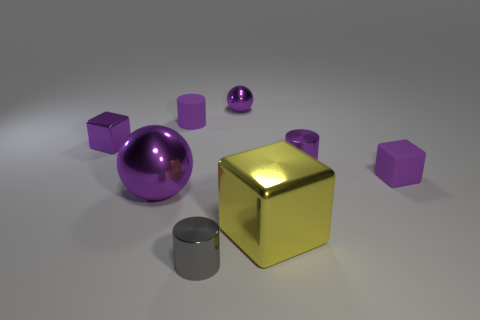Add 1 rubber blocks. How many objects exist? 9 Subtract all balls. How many objects are left? 6 Add 3 blue matte things. How many blue matte things exist? 3 Subtract 1 purple cylinders. How many objects are left? 7 Subtract all purple cylinders. Subtract all small purple spheres. How many objects are left? 5 Add 7 gray shiny things. How many gray shiny things are left? 8 